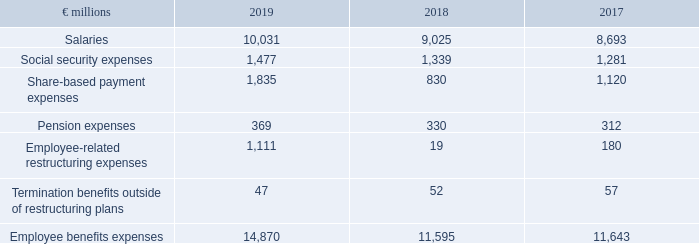(B.2) Employee Benefits Expenses
Components of Employee Benefits Expenses
What is the amount of employee benefits expenses in 2019?
Answer scale should be: million. 14,870. In which years are the employee benefits expenses calculated? 2019, 2018, 2017. What are the components considered under employee benefit expenses in the table? Salaries, social security expenses, share-based payment expenses, pension expenses, employee-related restructuring expenses, termination benefits outside of restructuring plans. In which year were the Termination benefits outside of restructuring plans the largest? 57>52>47
Answer: 2017. What was the change in Pension expenses in 2019 from 2018?
Answer scale should be: million. 369-330
Answer: 39. What was the percentage change in Pension expenses in 2019 from 2018?
Answer scale should be: percent. (369-330)/330
Answer: 11.82. 